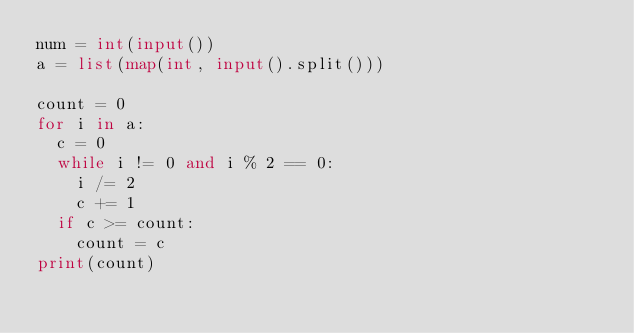Convert code to text. <code><loc_0><loc_0><loc_500><loc_500><_Python_>num = int(input())
a = list(map(int, input().split()))

count = 0
for i in a:
  c = 0
  while i != 0 and i % 2 == 0:
    i /= 2
    c += 1
  if c >= count:
    count = c
print(count)</code> 